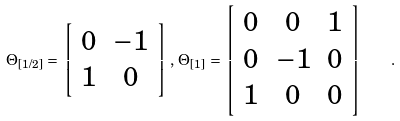Convert formula to latex. <formula><loc_0><loc_0><loc_500><loc_500>\Theta _ { [ 1 / 2 ] } \, = \, \left [ \begin{array} { c c c } { 0 } & { - 1 } \\ { 1 } & { 0 } \end{array} \right ] \, , \, \Theta _ { [ 1 ] } \, = \, \left [ \begin{array} { c c c c c } { 0 } & { 0 } & { 1 } \\ { 0 } & { - 1 } & { 0 } \\ { 1 } & { 0 } & { 0 } \end{array} \right ] \quad .</formula> 